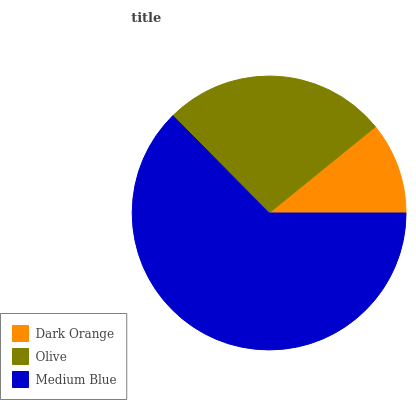Is Dark Orange the minimum?
Answer yes or no. Yes. Is Medium Blue the maximum?
Answer yes or no. Yes. Is Olive the minimum?
Answer yes or no. No. Is Olive the maximum?
Answer yes or no. No. Is Olive greater than Dark Orange?
Answer yes or no. Yes. Is Dark Orange less than Olive?
Answer yes or no. Yes. Is Dark Orange greater than Olive?
Answer yes or no. No. Is Olive less than Dark Orange?
Answer yes or no. No. Is Olive the high median?
Answer yes or no. Yes. Is Olive the low median?
Answer yes or no. Yes. Is Dark Orange the high median?
Answer yes or no. No. Is Dark Orange the low median?
Answer yes or no. No. 